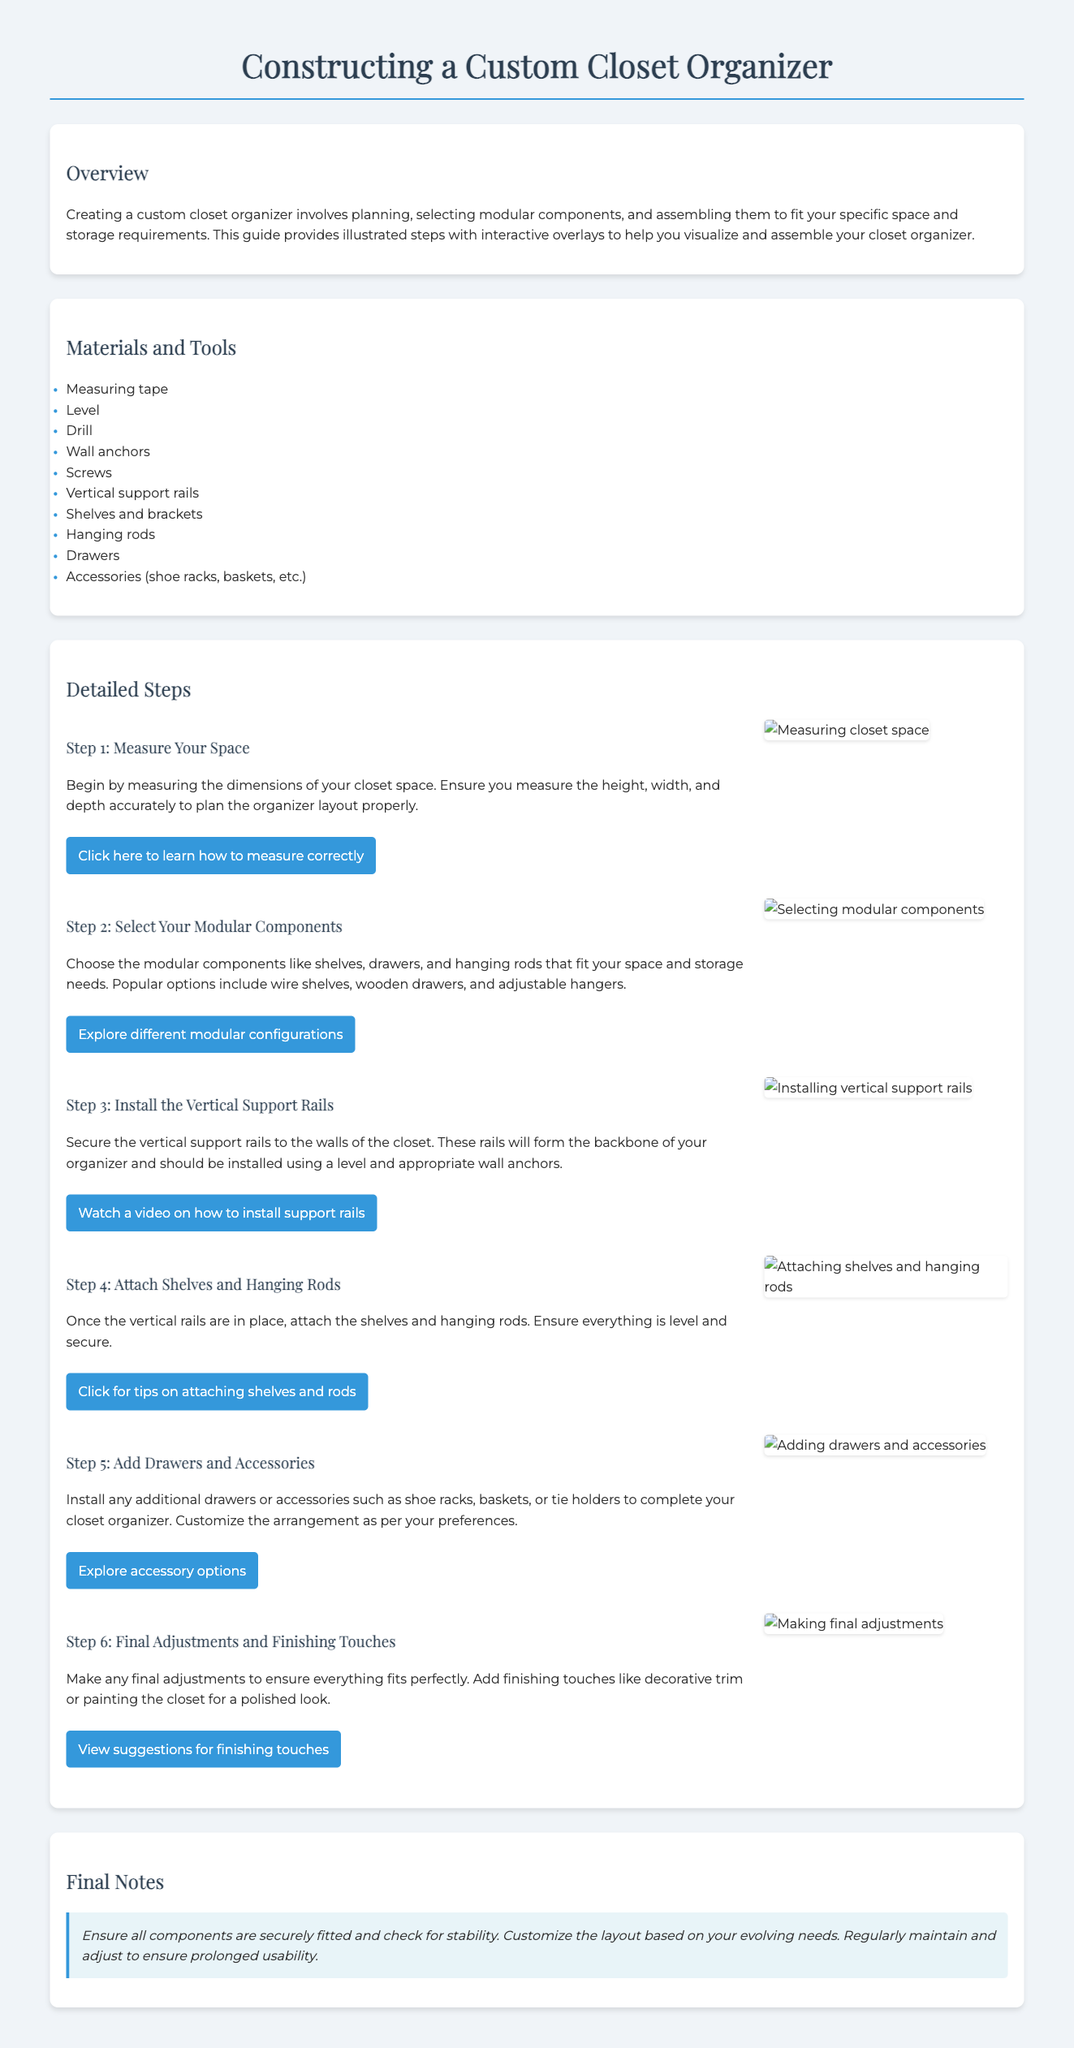What is the title of the document? The title appears at the top of the document and describes the main focus.
Answer: Constructing a Custom Closet Organizer How many detailed steps are there in the assembly instructions? The steps section outlines the process in a numbered format.
Answer: 6 What is the first step in assembling the custom closet organizer? The detailed steps begin with measuring the closet space.
Answer: Measure Your Space What tool is specifically mentioned for ensuring the vertical support rails are level? The tools and materials listed help highlight essential equipment needed for assembly.
Answer: Level In which step do you add drawers and accessories? The sequence of steps details when to incorporate these elements into the assembly process.
Answer: Step 5 What color is the background of the final notes section? The design and layout of the document follows specific color schemes for different sections.
Answer: Light blue Which modular component is suggested for storing shoes? Accessories are mentioned for optimizing closet organization, indicating their specific uses.
Answer: Shoe racks What action should be taken for finishing touches? The last step includes advice on enhancing the appearance of the closet organizer.
Answer: Add decorative trim What method is provided for visualizing how to measure correctly? The interactive elements within the document allow for engaging ways to understand the assembly process.
Answer: Click here to learn how to measure correctly 